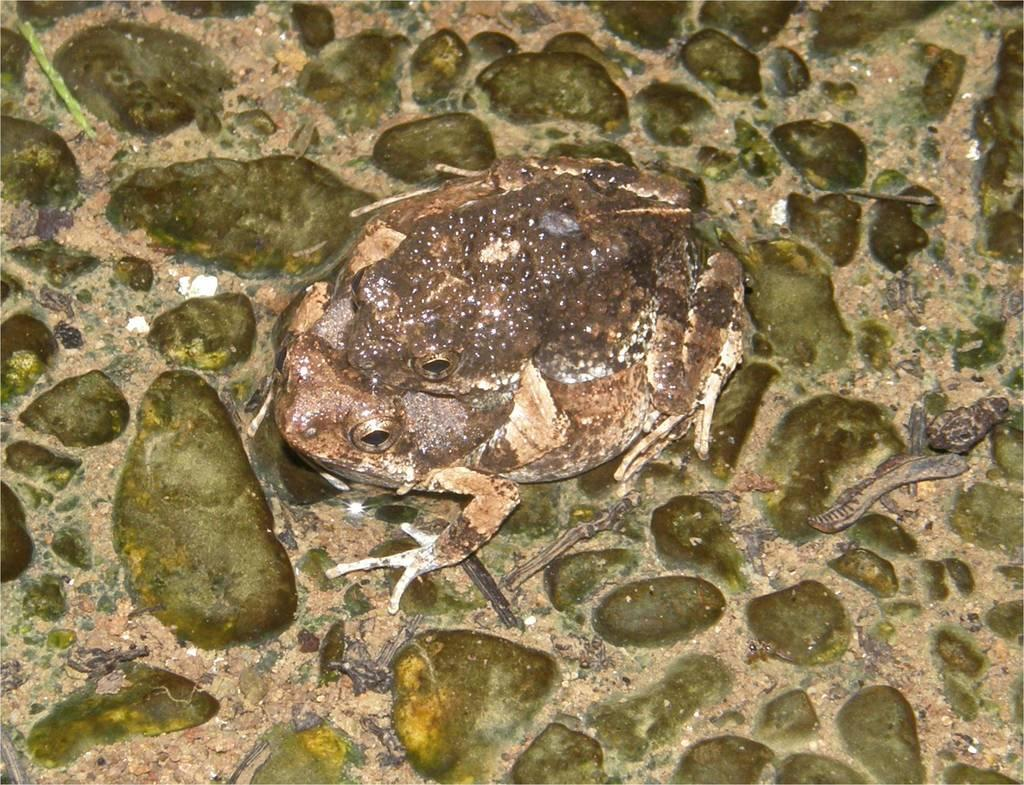What is the main subject in the center of the image? There is a frog in the center of the image. Can you describe the position of the frog in the image? The frog is on the surface. What color is the orange that the frog is holding in the image? There is no orange present in the image, and the frog is not holding anything. What type of muscle can be seen in the image? There is no muscle visible in the image; it features a frog on the surface. 